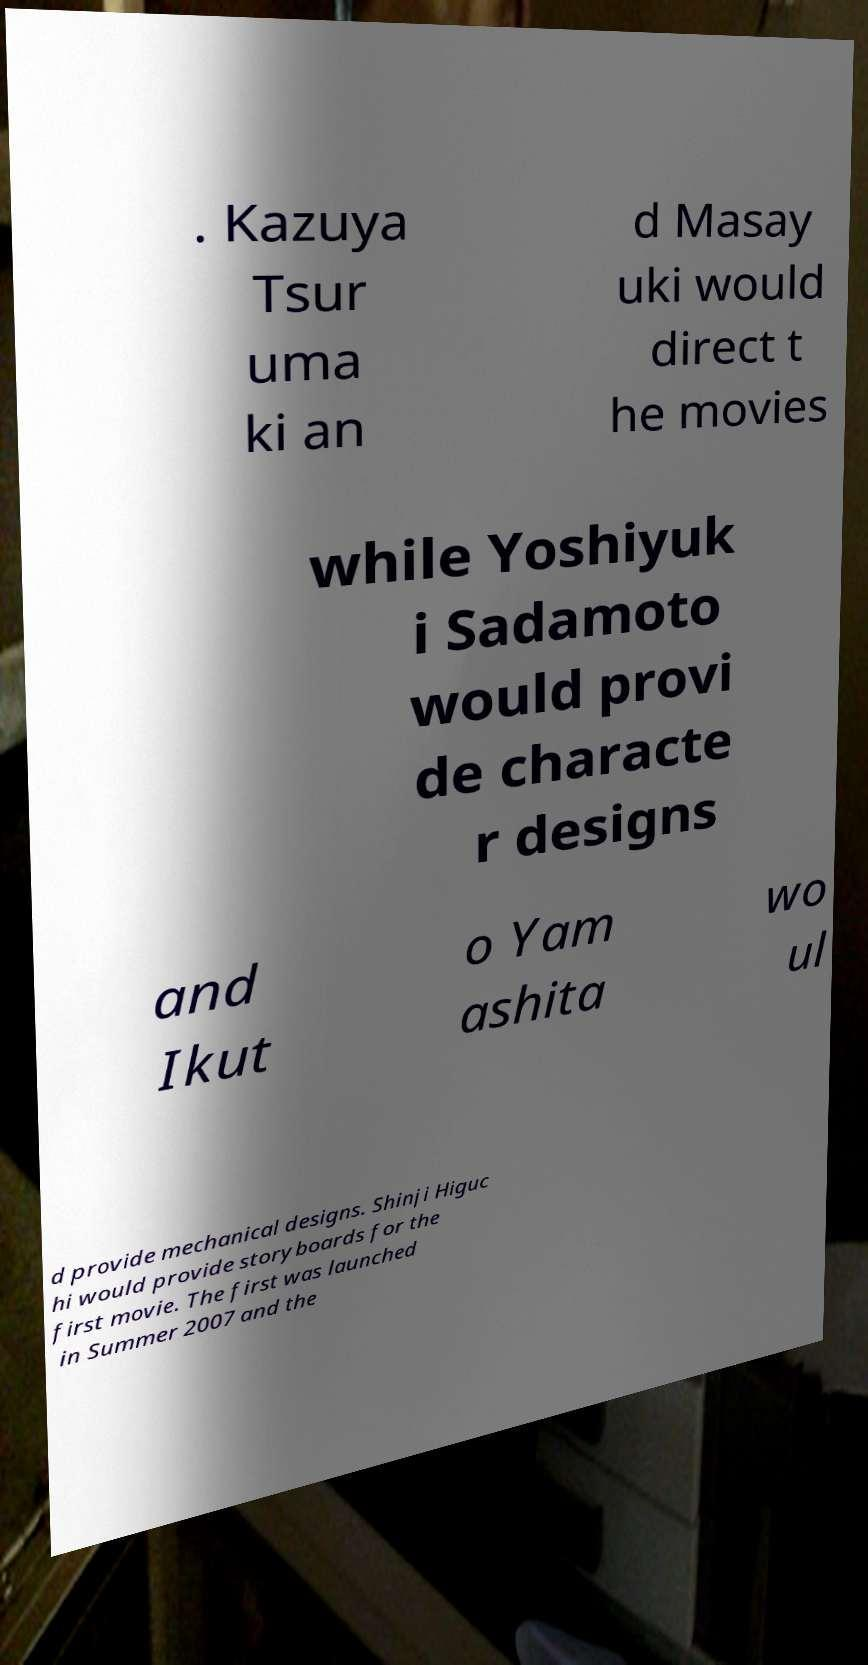Could you extract and type out the text from this image? . Kazuya Tsur uma ki an d Masay uki would direct t he movies while Yoshiyuk i Sadamoto would provi de characte r designs and Ikut o Yam ashita wo ul d provide mechanical designs. Shinji Higuc hi would provide storyboards for the first movie. The first was launched in Summer 2007 and the 